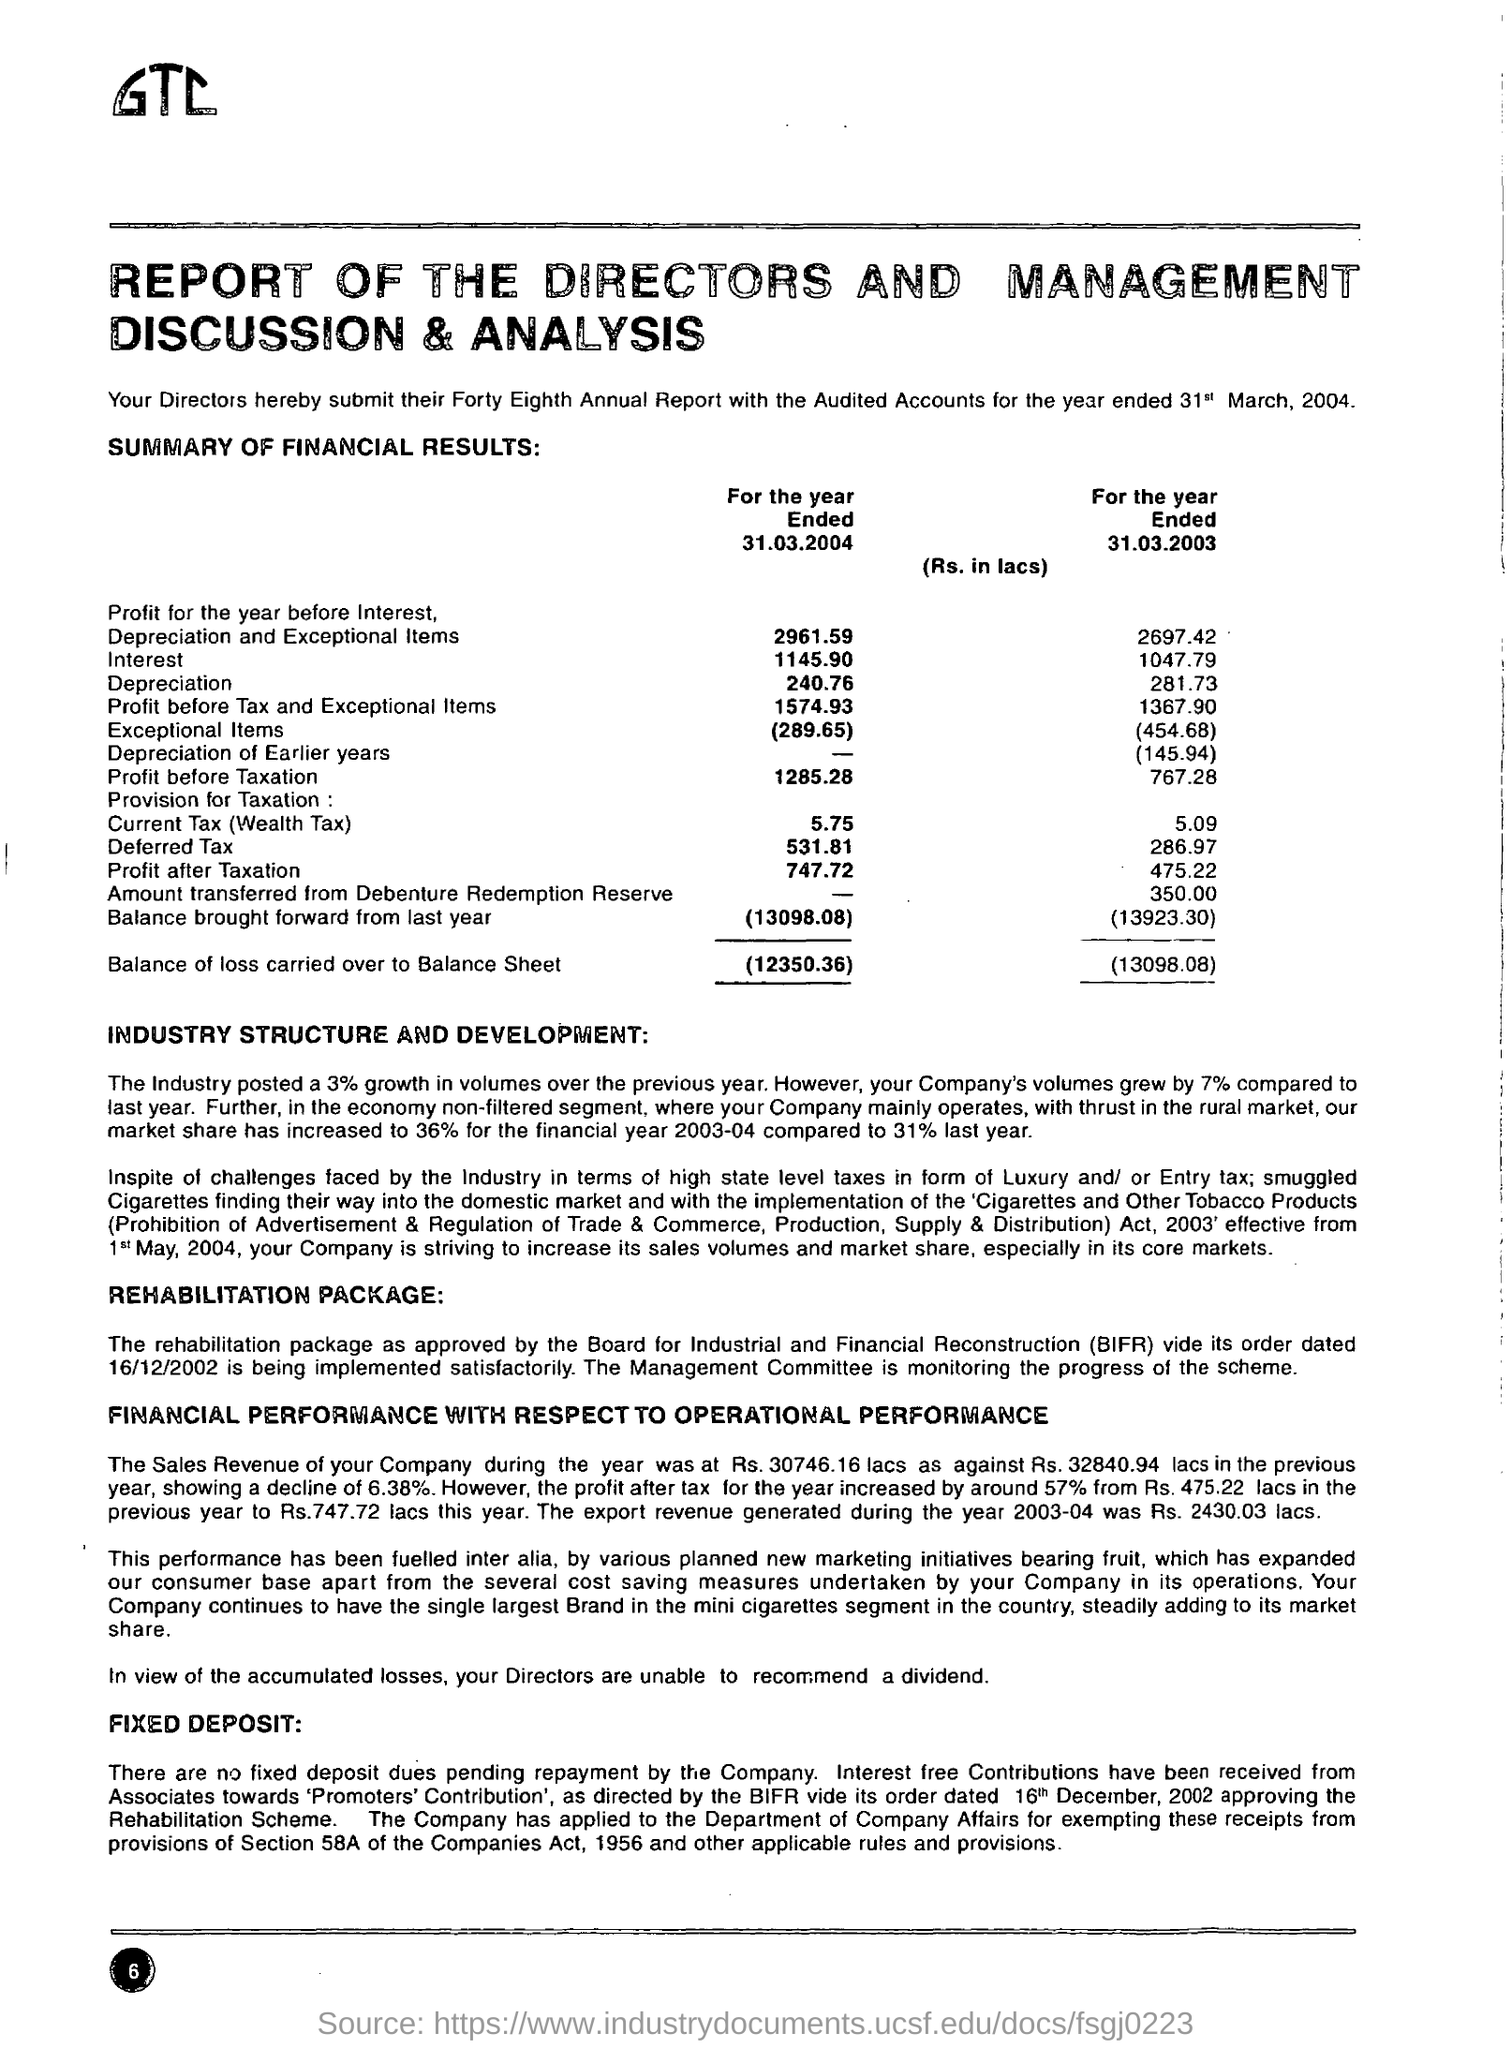What is the amount of profit after taxation for the year ended 31.03.2004 ?
Provide a short and direct response. 747.72. What is the amount of interest for the year ended 31.03.2003 ?
Offer a terse response. 1047.79 lacs. What is the amount of balance of loss carried over to balance sheet for the year ended 31.03.2004 ?
Ensure brevity in your answer.  12350.36 lacs. What is the amount of current tax(wealth tax) shown in the report for the year ended 31.03.2004 ?
Offer a very short reply. 5.75 lacs. What is the amount of of depreciation shown in the report for the year ended 31.03.2003 ?
Provide a succinct answer. 281.73. Which annual report has been submitted by the directors with the audited accounts for the year ended 31st march,2004 ?
Your answer should be compact. Forty eighth. What is the full form of bifr ?
Make the answer very short. Board for industrial and financial reconstruction. How much percentage growth in volumes has been posted by the industry over the previous year ?
Give a very brief answer. 3%. How much percentage of market share has increased for the financial year 2003-04 ?
Your response must be concise. 36. What is the amount of depreciation and exceptional items shown in the report for the year ended 31.03.2004 ?
Give a very brief answer. 2961.59 lacs. 